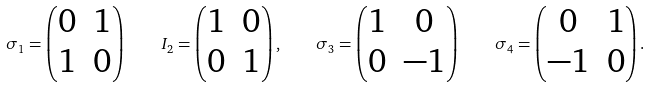Convert formula to latex. <formula><loc_0><loc_0><loc_500><loc_500>\sigma _ { 1 } = \begin{pmatrix} 0 & 1 \\ 1 & 0 \end{pmatrix} \quad I _ { 2 } = \begin{pmatrix} 1 & 0 \\ 0 & 1 \end{pmatrix} , \quad \sigma _ { 3 } = \begin{pmatrix} 1 & 0 \\ 0 & - 1 \end{pmatrix} \quad \sigma _ { 4 } = \begin{pmatrix} 0 & 1 \\ - 1 & 0 \end{pmatrix} .</formula> 